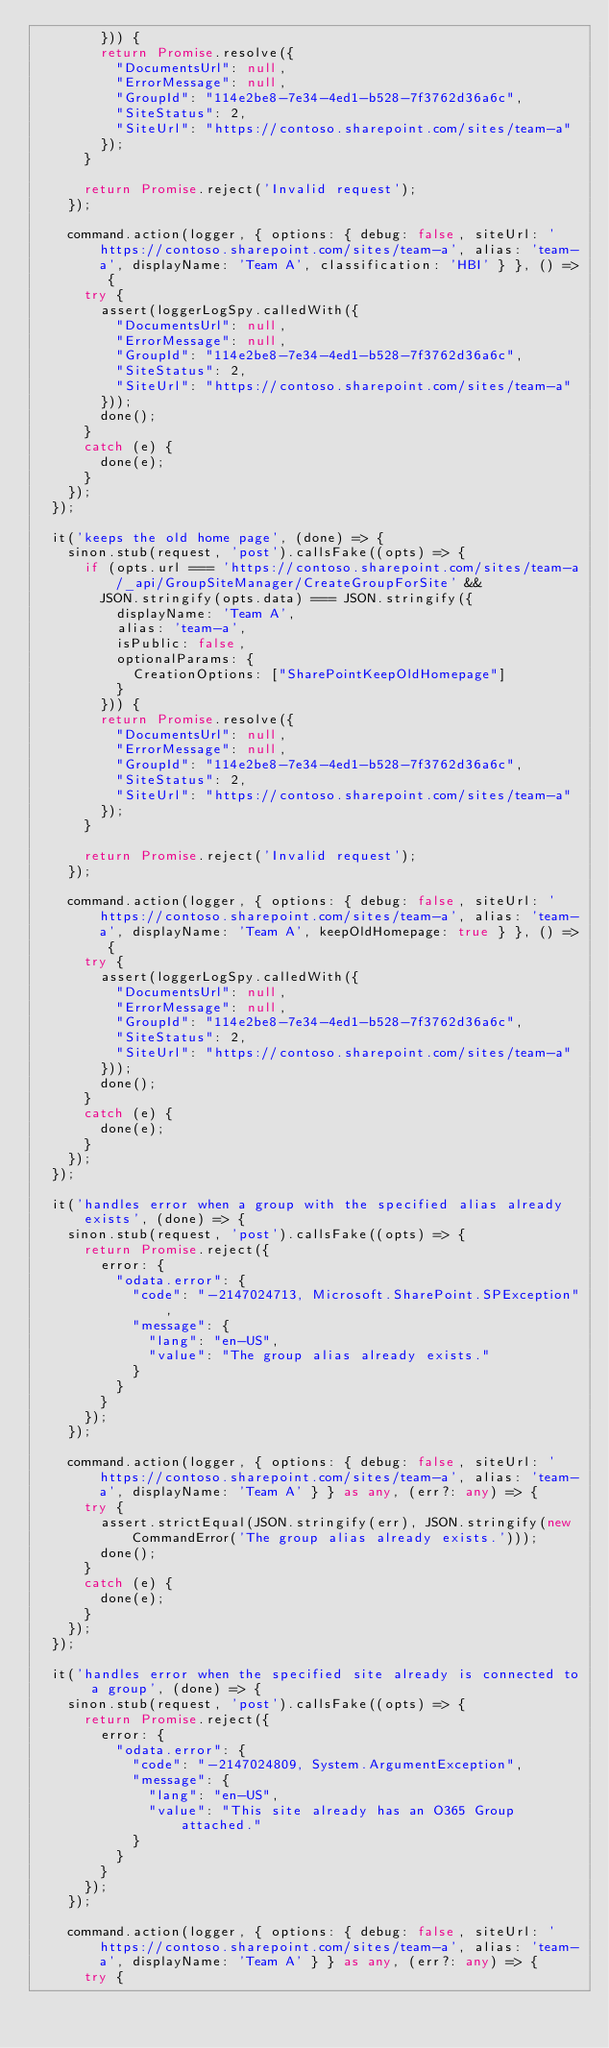Convert code to text. <code><loc_0><loc_0><loc_500><loc_500><_TypeScript_>        })) {
        return Promise.resolve({
          "DocumentsUrl": null,
          "ErrorMessage": null,
          "GroupId": "114e2be8-7e34-4ed1-b528-7f3762d36a6c",
          "SiteStatus": 2,
          "SiteUrl": "https://contoso.sharepoint.com/sites/team-a"
        });
      }

      return Promise.reject('Invalid request');
    });

    command.action(logger, { options: { debug: false, siteUrl: 'https://contoso.sharepoint.com/sites/team-a', alias: 'team-a', displayName: 'Team A', classification: 'HBI' } }, () => {
      try {
        assert(loggerLogSpy.calledWith({
          "DocumentsUrl": null,
          "ErrorMessage": null,
          "GroupId": "114e2be8-7e34-4ed1-b528-7f3762d36a6c",
          "SiteStatus": 2,
          "SiteUrl": "https://contoso.sharepoint.com/sites/team-a"
        }));
        done();
      }
      catch (e) {
        done(e);
      }
    });
  });

  it('keeps the old home page', (done) => {
    sinon.stub(request, 'post').callsFake((opts) => {
      if (opts.url === 'https://contoso.sharepoint.com/sites/team-a/_api/GroupSiteManager/CreateGroupForSite' &&
        JSON.stringify(opts.data) === JSON.stringify({
          displayName: 'Team A',
          alias: 'team-a',
          isPublic: false,
          optionalParams: {
            CreationOptions: ["SharePointKeepOldHomepage"]
          }
        })) {
        return Promise.resolve({
          "DocumentsUrl": null,
          "ErrorMessage": null,
          "GroupId": "114e2be8-7e34-4ed1-b528-7f3762d36a6c",
          "SiteStatus": 2,
          "SiteUrl": "https://contoso.sharepoint.com/sites/team-a"
        });
      }

      return Promise.reject('Invalid request');
    });

    command.action(logger, { options: { debug: false, siteUrl: 'https://contoso.sharepoint.com/sites/team-a', alias: 'team-a', displayName: 'Team A', keepOldHomepage: true } }, () => {
      try {
        assert(loggerLogSpy.calledWith({
          "DocumentsUrl": null,
          "ErrorMessage": null,
          "GroupId": "114e2be8-7e34-4ed1-b528-7f3762d36a6c",
          "SiteStatus": 2,
          "SiteUrl": "https://contoso.sharepoint.com/sites/team-a"
        }));
        done();
      }
      catch (e) {
        done(e);
      }
    });
  });

  it('handles error when a group with the specified alias already exists', (done) => {
    sinon.stub(request, 'post').callsFake((opts) => {
      return Promise.reject({
        error: {
          "odata.error": {
            "code": "-2147024713, Microsoft.SharePoint.SPException",
            "message": {
              "lang": "en-US",
              "value": "The group alias already exists."
            }
          }
        }
      });
    });

    command.action(logger, { options: { debug: false, siteUrl: 'https://contoso.sharepoint.com/sites/team-a', alias: 'team-a', displayName: 'Team A' } } as any, (err?: any) => {
      try {
        assert.strictEqual(JSON.stringify(err), JSON.stringify(new CommandError('The group alias already exists.')));
        done();
      }
      catch (e) {
        done(e);
      }
    });
  });

  it('handles error when the specified site already is connected to a group', (done) => {
    sinon.stub(request, 'post').callsFake((opts) => {
      return Promise.reject({
        error: {
          "odata.error": {
            "code": "-2147024809, System.ArgumentException",
            "message": {
              "lang": "en-US",
              "value": "This site already has an O365 Group attached."
            }
          }
        }
      });
    });

    command.action(logger, { options: { debug: false, siteUrl: 'https://contoso.sharepoint.com/sites/team-a', alias: 'team-a', displayName: 'Team A' } } as any, (err?: any) => {
      try {</code> 